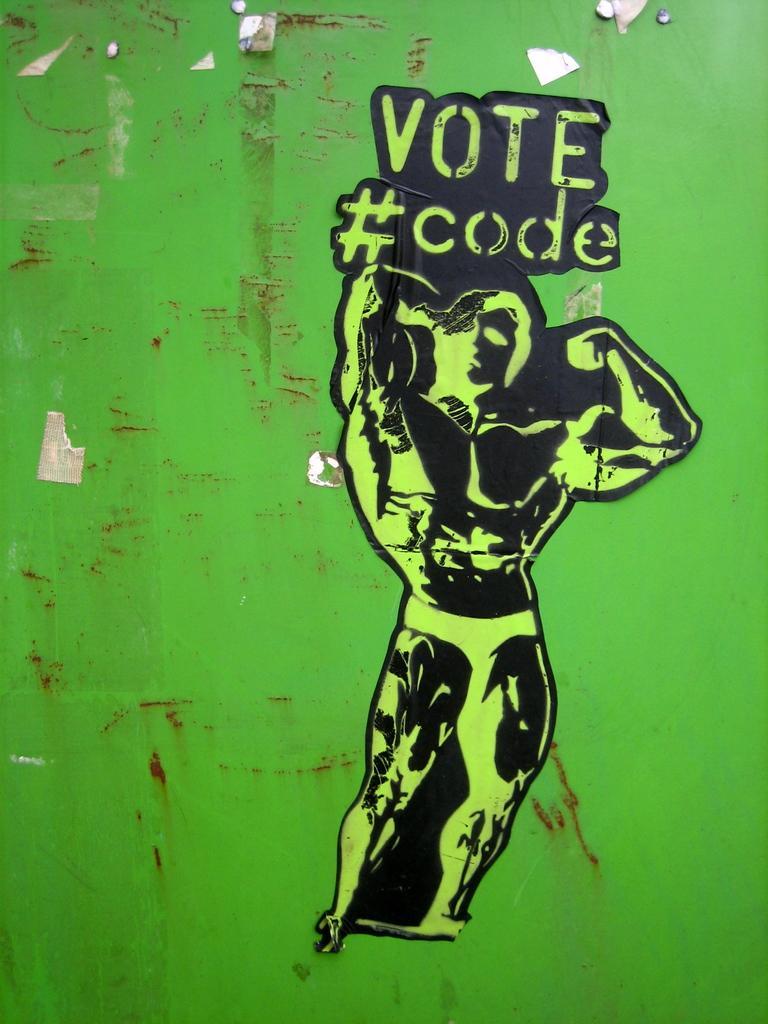In one or two sentences, can you explain what this image depicts? In this image we can see the green color wall on which we can see the sticker of a person and we can see some text here. 